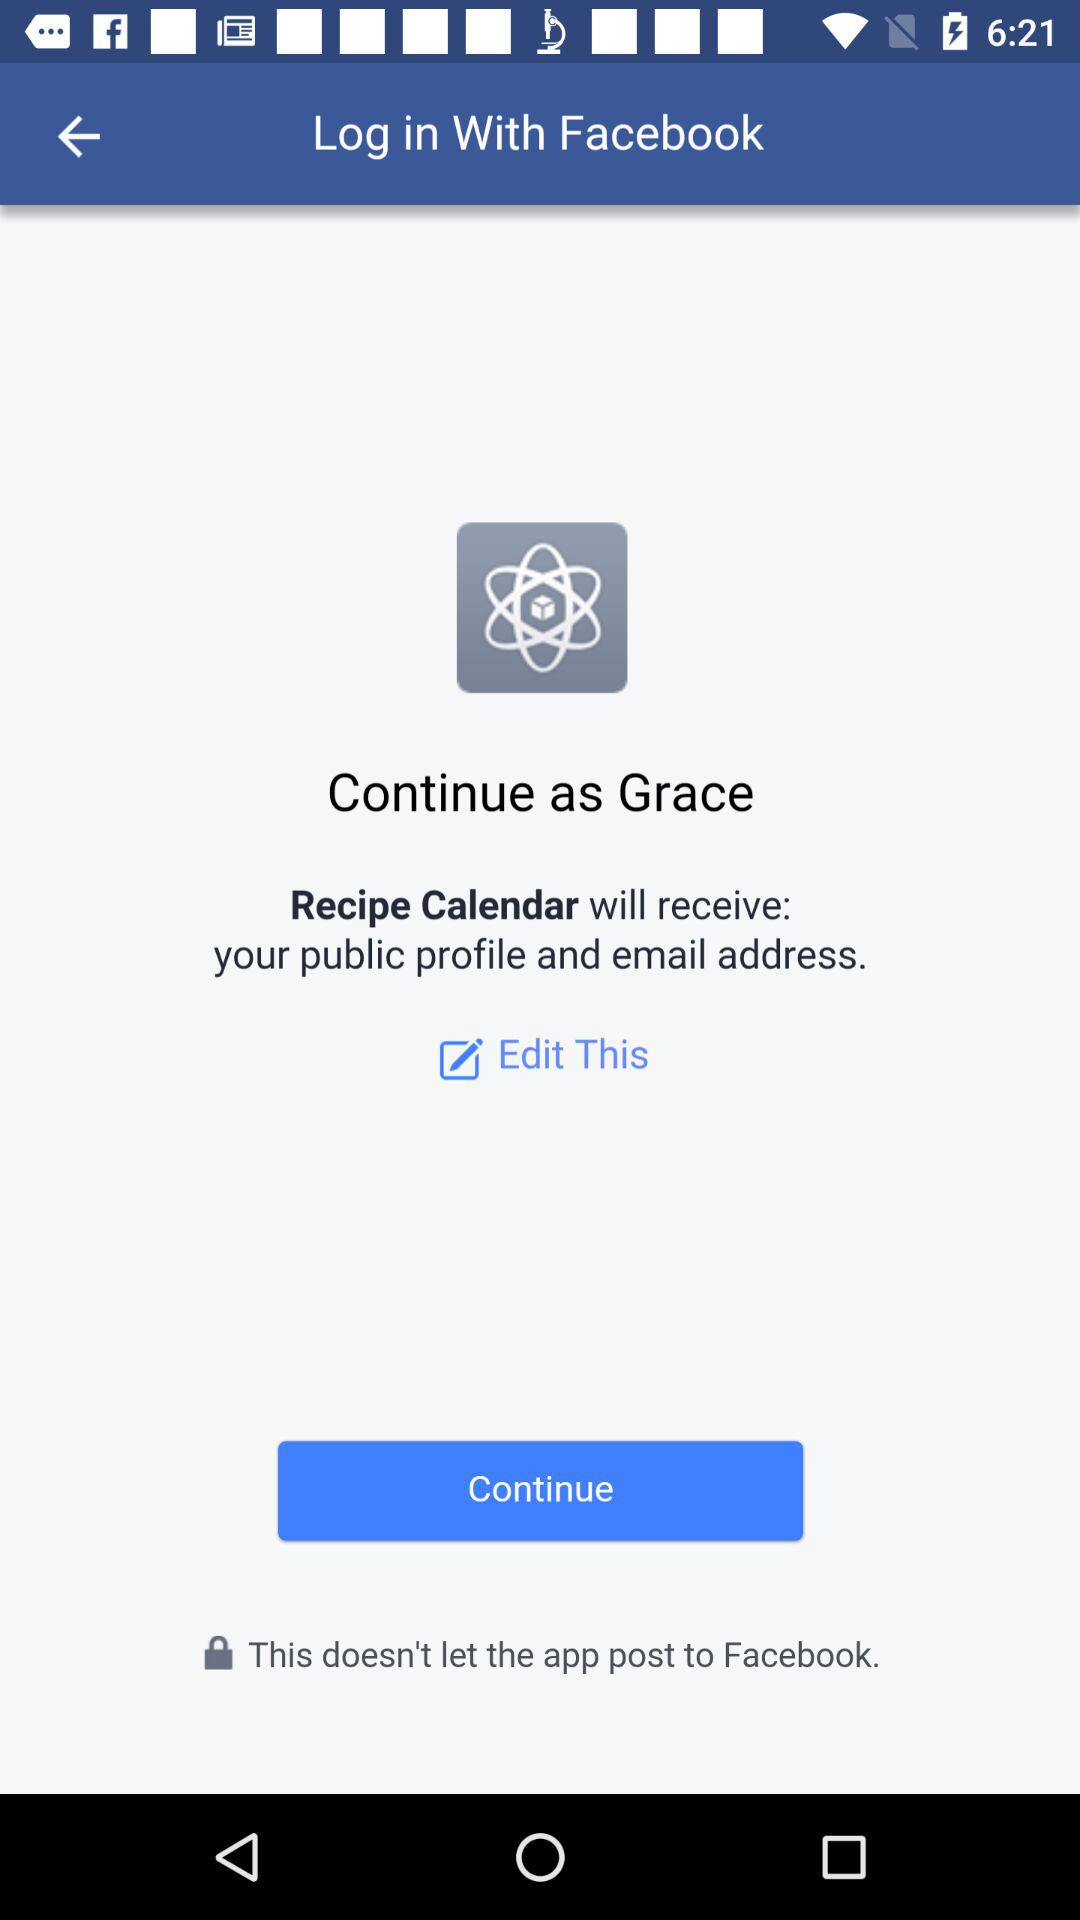What's the name of the user by whom the application can be continued? The name of the user is Grace. 